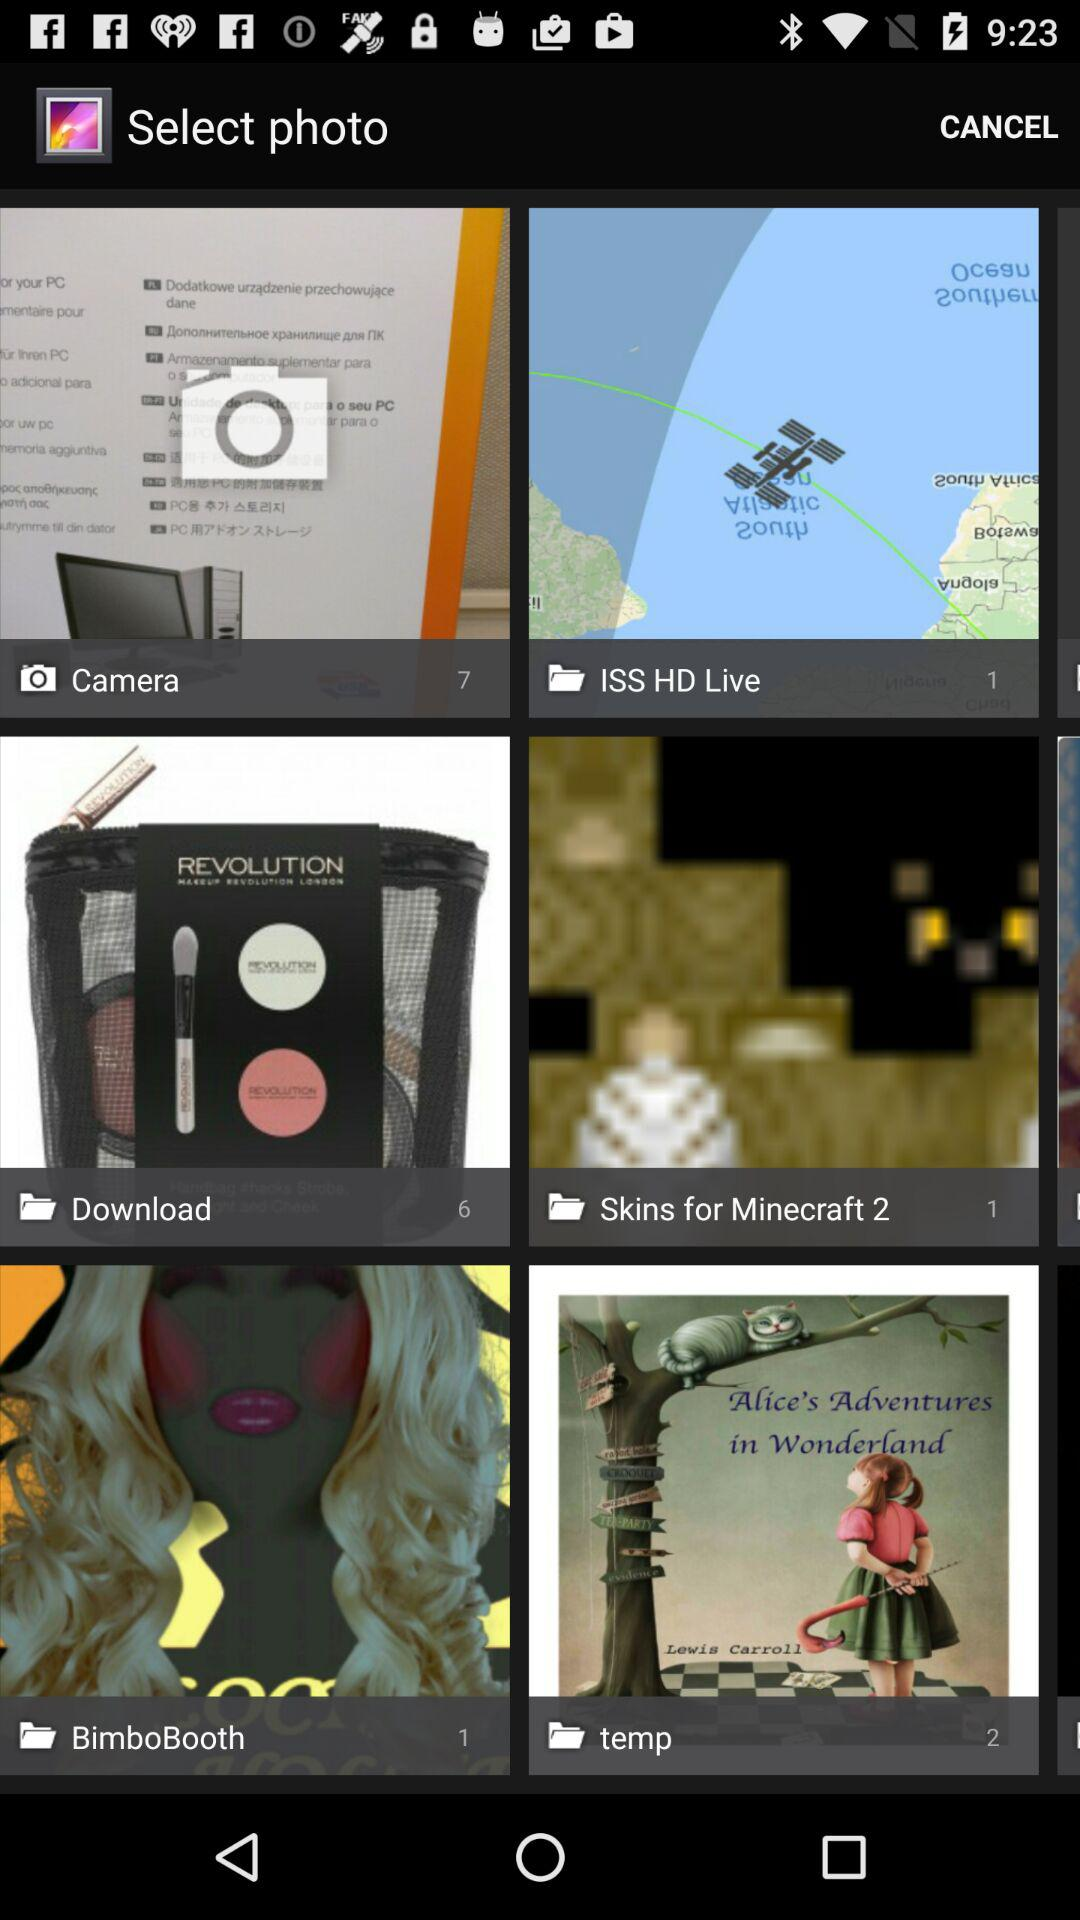Who wrote "Alice's Adventures in Wonderland"?
When the provided information is insufficient, respond with <no answer>. <no answer> 